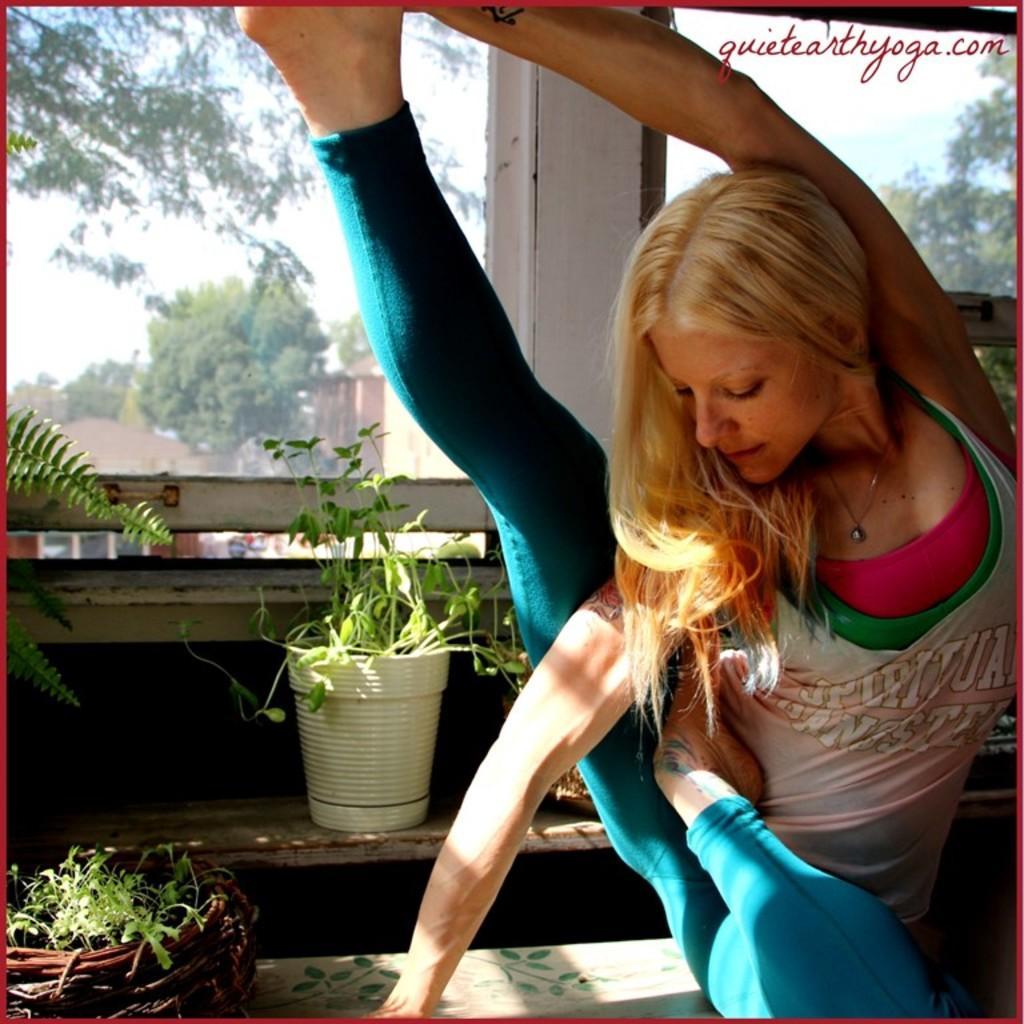Can you describe this image briefly? In this picture we can see a woman, beside to her we can find few plants, in the background we can find few trees and houses. 